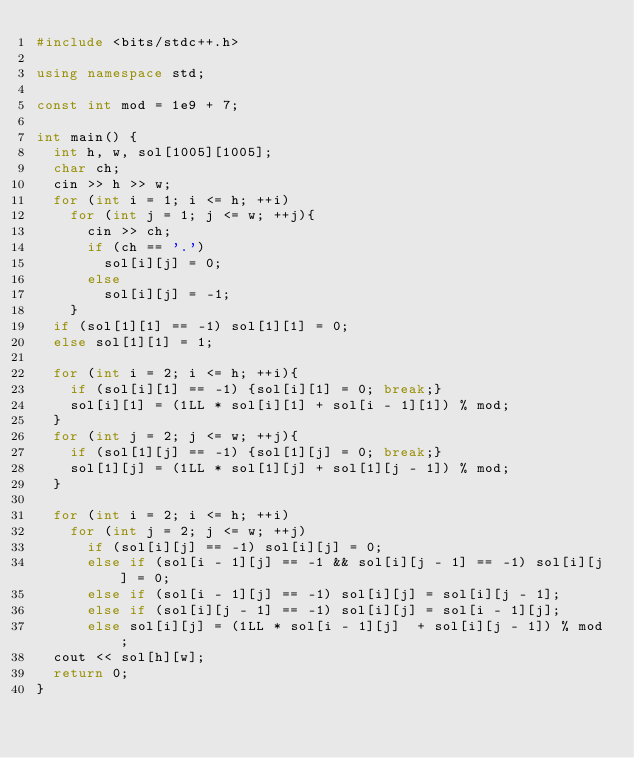Convert code to text. <code><loc_0><loc_0><loc_500><loc_500><_C++_>#include <bits/stdc++.h>

using namespace std;

const int mod = 1e9 + 7;

int main() {
	int h, w, sol[1005][1005];
	char ch;
	cin >> h >> w;
	for (int i = 1; i <= h; ++i)
		for (int j = 1; j <= w; ++j){
			cin >> ch;
			if (ch == '.')
				sol[i][j] = 0;
			else
				sol[i][j] = -1;
		}
	if (sol[1][1] == -1) sol[1][1] = 0;
	else sol[1][1] = 1;
	
	for (int i = 2; i <= h; ++i){
		if (sol[i][1] == -1) {sol[i][1] = 0; break;}
		sol[i][1] = (1LL * sol[i][1] + sol[i - 1][1]) % mod;
	}
	for (int j = 2; j <= w; ++j){
		if (sol[1][j] == -1) {sol[1][j] = 0; break;}
		sol[1][j] = (1LL * sol[1][j] + sol[1][j - 1]) % mod;
	}
	
	for (int i = 2; i <= h; ++i)
		for (int j = 2; j <= w; ++j)
			if (sol[i][j] == -1) sol[i][j] = 0;
			else if (sol[i - 1][j] == -1 && sol[i][j - 1] == -1) sol[i][j] = 0;
			else if (sol[i - 1][j] == -1) sol[i][j] = sol[i][j - 1];
			else if (sol[i][j - 1] == -1) sol[i][j] = sol[i - 1][j];
			else sol[i][j] = (1LL * sol[i - 1][j]  + sol[i][j - 1]) % mod;
	cout << sol[h][w];
	return 0;
}</code> 